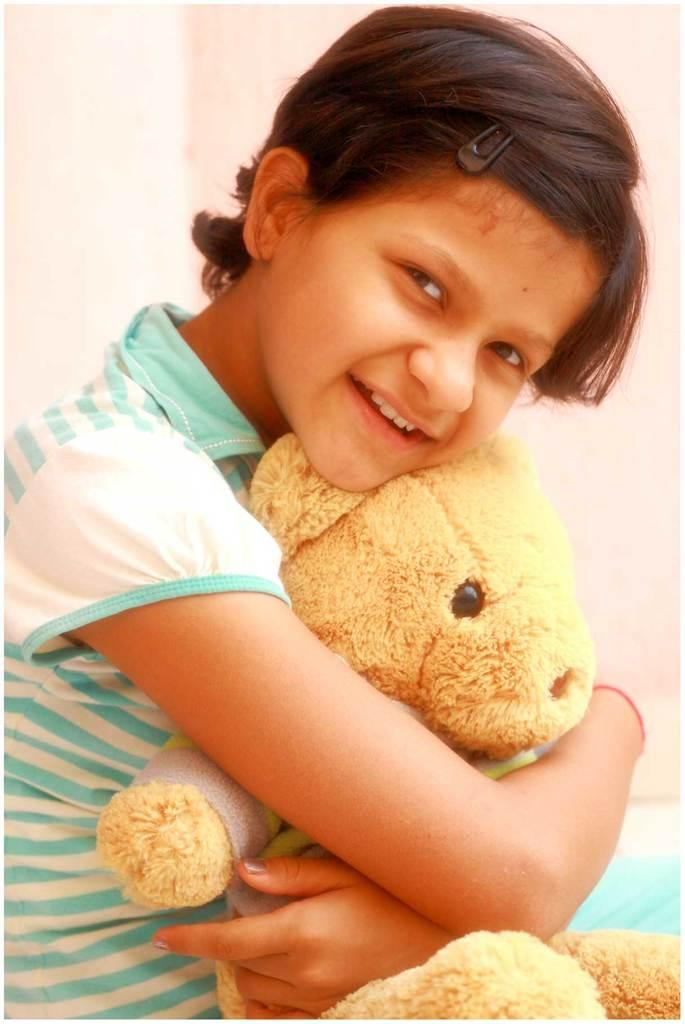Who is the main subject in the image? There is a girl in the image. What is the girl holding in the image? The girl is holding a toy. What is the girl doing in the image? The girl is posing for a photo. What can be seen in the background of the image? There is a wall in the background of the image. What type of steel is being used to construct the salt shaker in the image? There is no salt shaker present in the image, and therefore no steel or construction can be observed. 